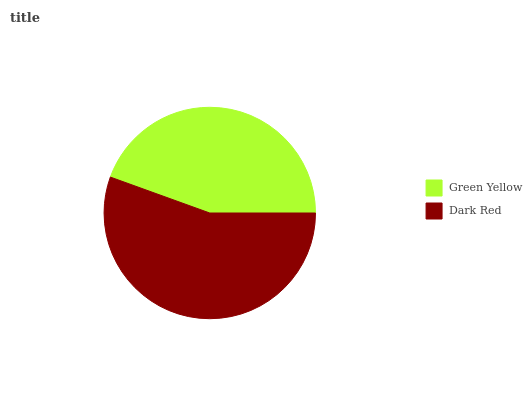Is Green Yellow the minimum?
Answer yes or no. Yes. Is Dark Red the maximum?
Answer yes or no. Yes. Is Dark Red the minimum?
Answer yes or no. No. Is Dark Red greater than Green Yellow?
Answer yes or no. Yes. Is Green Yellow less than Dark Red?
Answer yes or no. Yes. Is Green Yellow greater than Dark Red?
Answer yes or no. No. Is Dark Red less than Green Yellow?
Answer yes or no. No. Is Dark Red the high median?
Answer yes or no. Yes. Is Green Yellow the low median?
Answer yes or no. Yes. Is Green Yellow the high median?
Answer yes or no. No. Is Dark Red the low median?
Answer yes or no. No. 